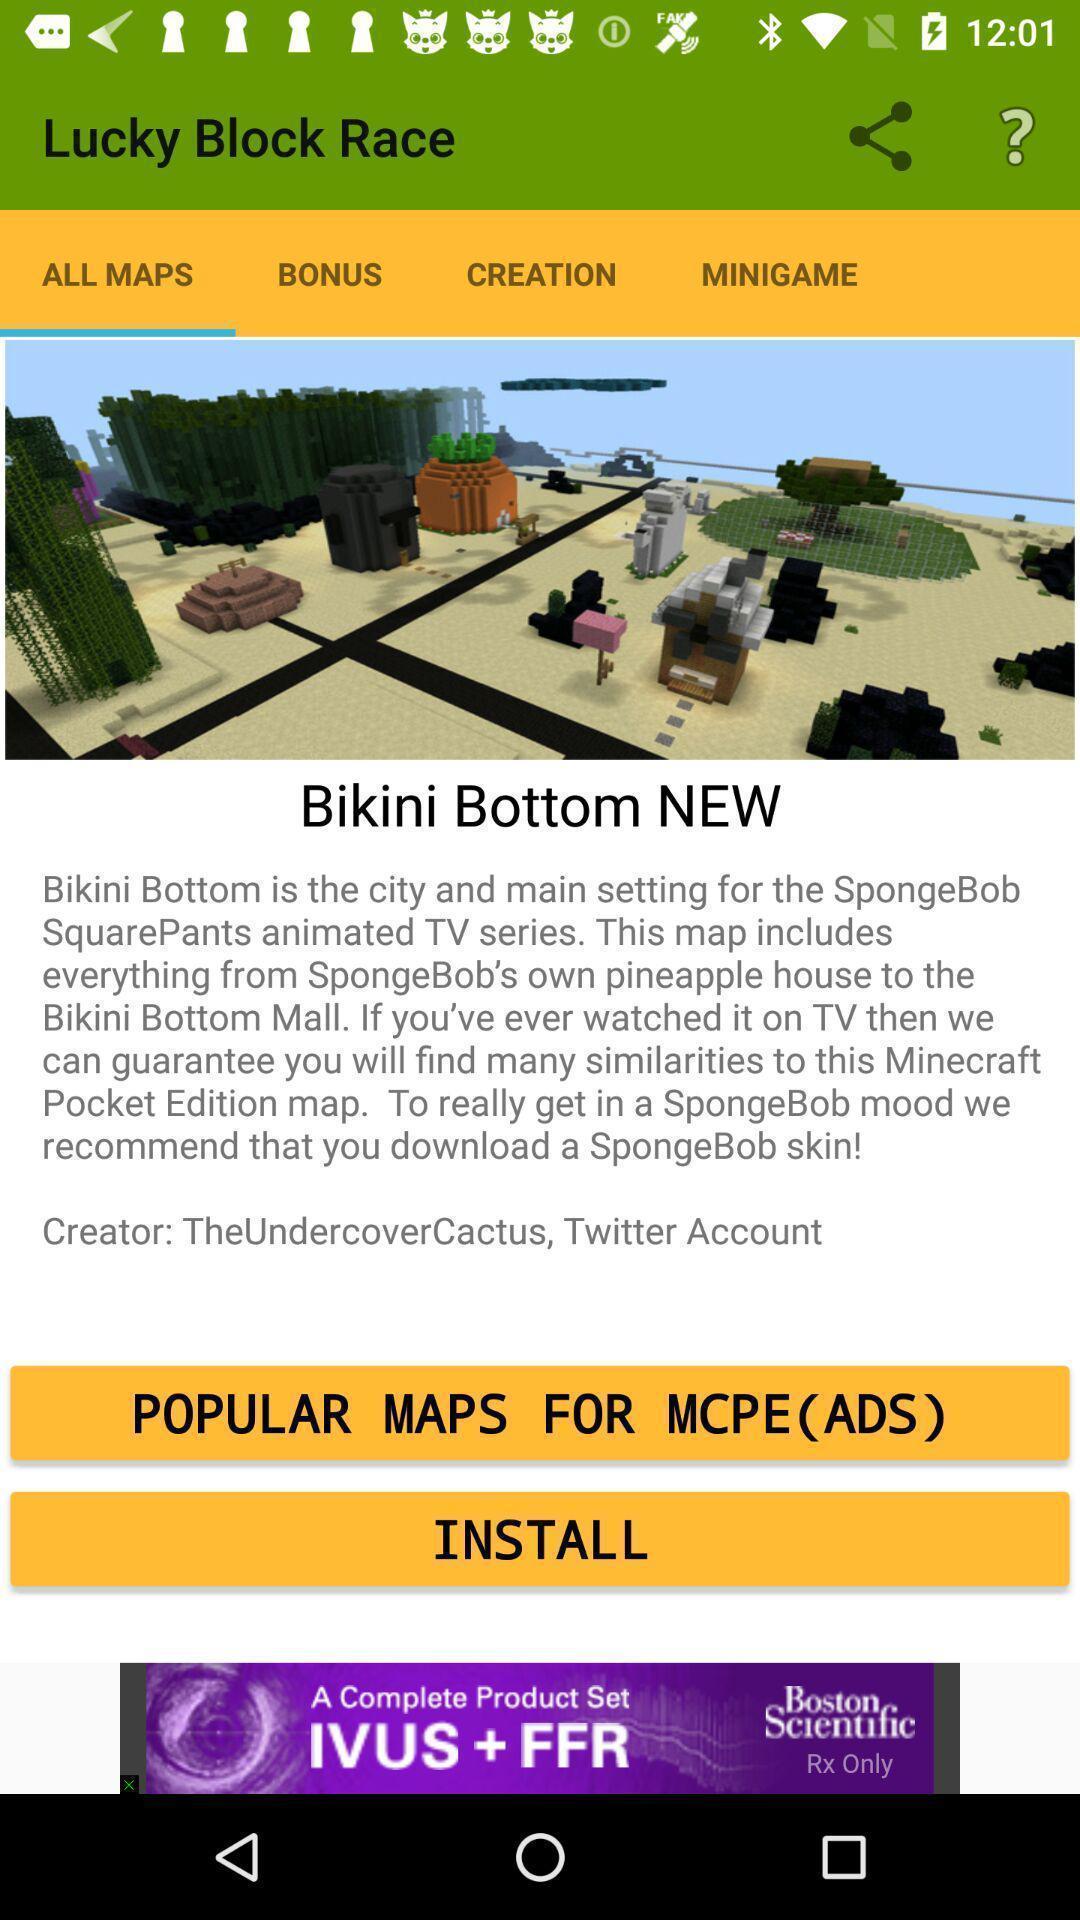Summarize the information in this screenshot. Screen displaying screen page. 